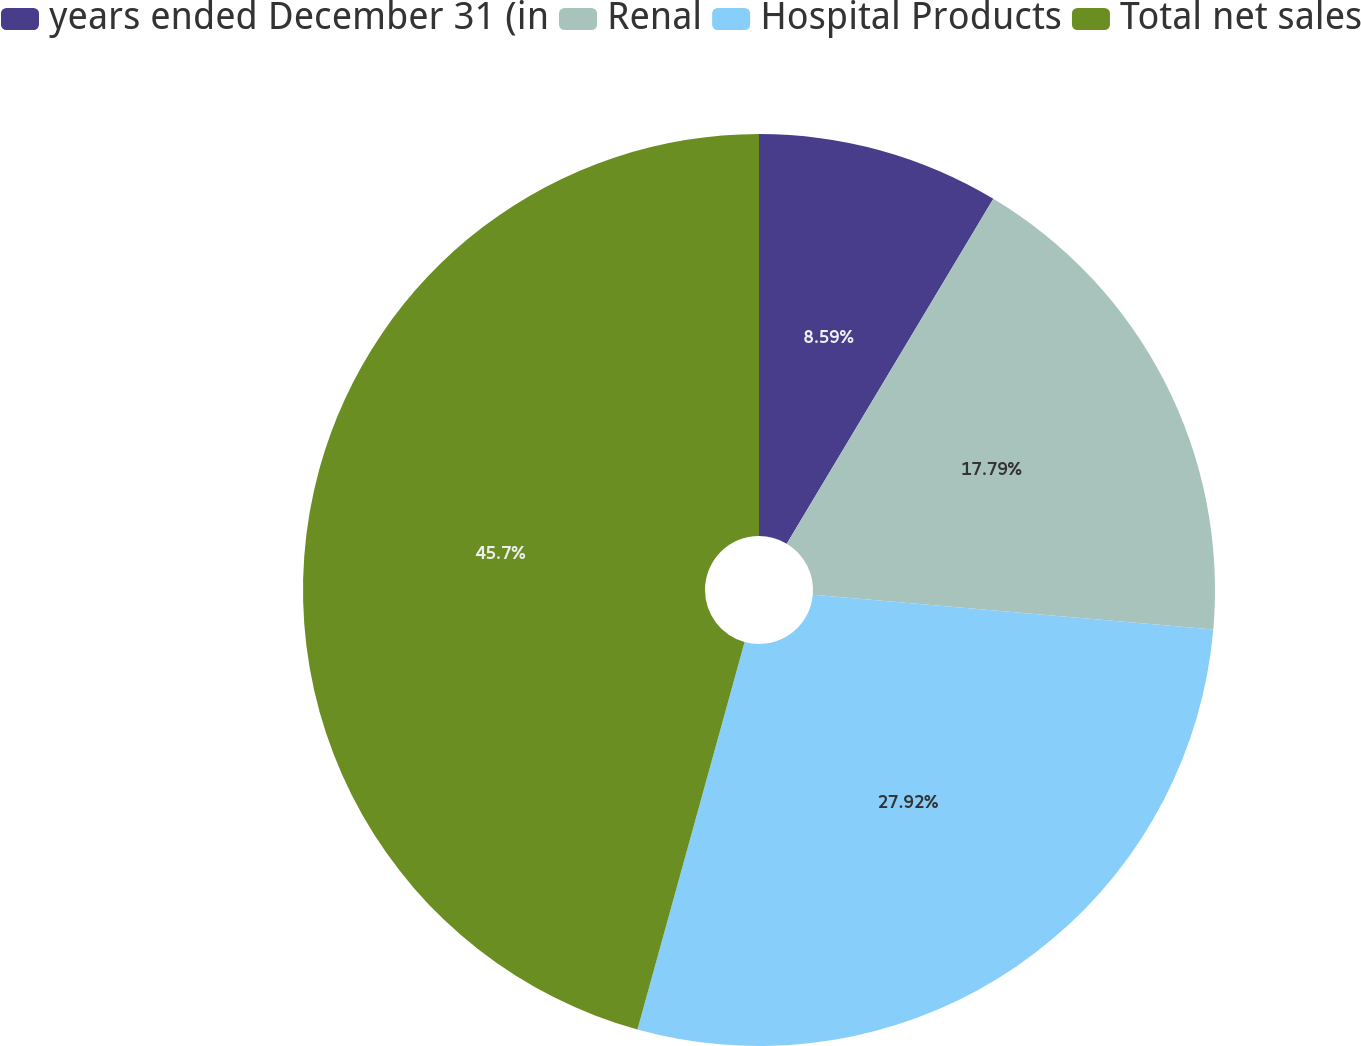<chart> <loc_0><loc_0><loc_500><loc_500><pie_chart><fcel>years ended December 31 (in<fcel>Renal<fcel>Hospital Products<fcel>Total net sales<nl><fcel>8.59%<fcel>17.79%<fcel>27.92%<fcel>45.71%<nl></chart> 